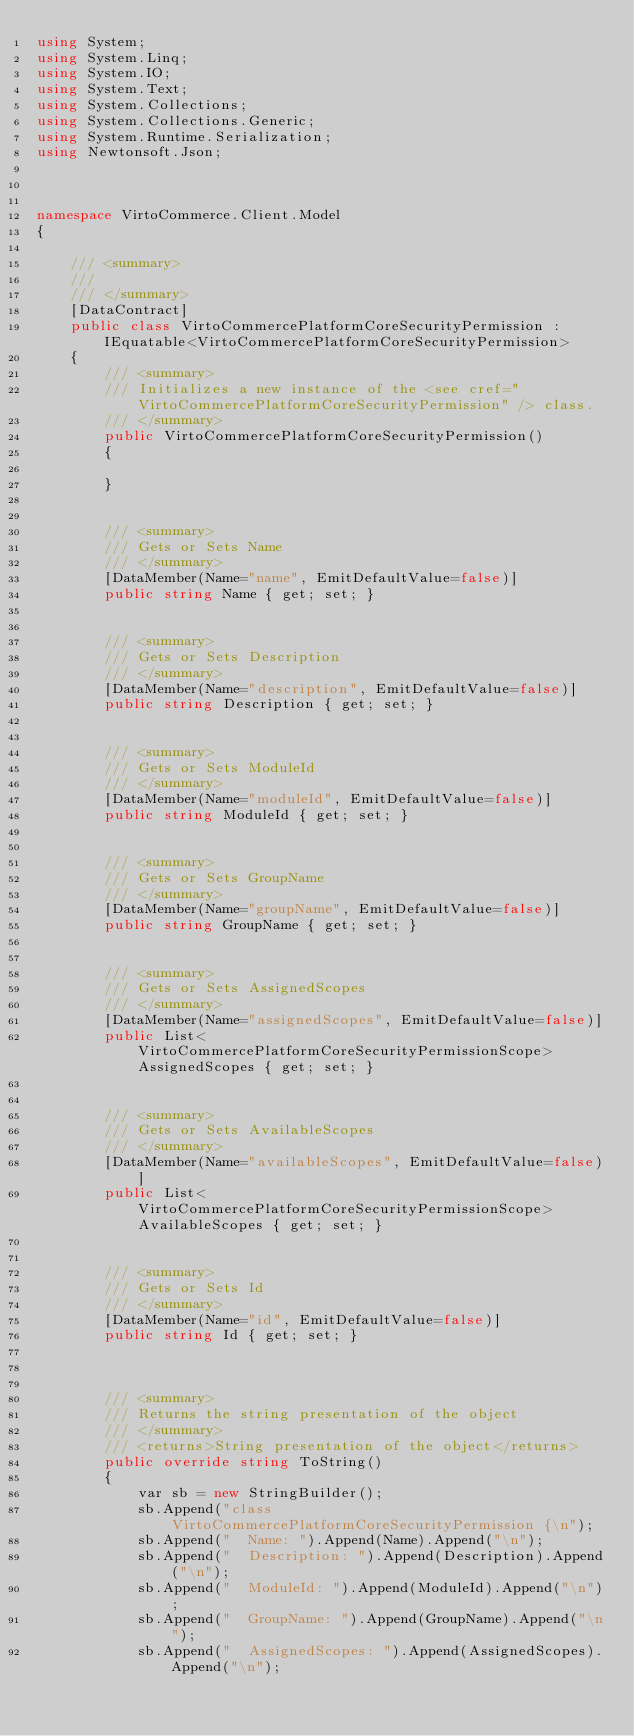Convert code to text. <code><loc_0><loc_0><loc_500><loc_500><_C#_>using System;
using System.Linq;
using System.IO;
using System.Text;
using System.Collections;
using System.Collections.Generic;
using System.Runtime.Serialization;
using Newtonsoft.Json;



namespace VirtoCommerce.Client.Model
{

    /// <summary>
    /// 
    /// </summary>
    [DataContract]
    public class VirtoCommercePlatformCoreSecurityPermission : IEquatable<VirtoCommercePlatformCoreSecurityPermission>
    {
        /// <summary>
        /// Initializes a new instance of the <see cref="VirtoCommercePlatformCoreSecurityPermission" /> class.
        /// </summary>
        public VirtoCommercePlatformCoreSecurityPermission()
        {
            
        }

        
        /// <summary>
        /// Gets or Sets Name
        /// </summary>
        [DataMember(Name="name", EmitDefaultValue=false)]
        public string Name { get; set; }
  
        
        /// <summary>
        /// Gets or Sets Description
        /// </summary>
        [DataMember(Name="description", EmitDefaultValue=false)]
        public string Description { get; set; }
  
        
        /// <summary>
        /// Gets or Sets ModuleId
        /// </summary>
        [DataMember(Name="moduleId", EmitDefaultValue=false)]
        public string ModuleId { get; set; }
  
        
        /// <summary>
        /// Gets or Sets GroupName
        /// </summary>
        [DataMember(Name="groupName", EmitDefaultValue=false)]
        public string GroupName { get; set; }
  
        
        /// <summary>
        /// Gets or Sets AssignedScopes
        /// </summary>
        [DataMember(Name="assignedScopes", EmitDefaultValue=false)]
        public List<VirtoCommercePlatformCoreSecurityPermissionScope> AssignedScopes { get; set; }
  
        
        /// <summary>
        /// Gets or Sets AvailableScopes
        /// </summary>
        [DataMember(Name="availableScopes", EmitDefaultValue=false)]
        public List<VirtoCommercePlatformCoreSecurityPermissionScope> AvailableScopes { get; set; }
  
        
        /// <summary>
        /// Gets or Sets Id
        /// </summary>
        [DataMember(Name="id", EmitDefaultValue=false)]
        public string Id { get; set; }
  
        
  
        /// <summary>
        /// Returns the string presentation of the object
        /// </summary>
        /// <returns>String presentation of the object</returns>
        public override string ToString()
        {
            var sb = new StringBuilder();
            sb.Append("class VirtoCommercePlatformCoreSecurityPermission {\n");
            sb.Append("  Name: ").Append(Name).Append("\n");
            sb.Append("  Description: ").Append(Description).Append("\n");
            sb.Append("  ModuleId: ").Append(ModuleId).Append("\n");
            sb.Append("  GroupName: ").Append(GroupName).Append("\n");
            sb.Append("  AssignedScopes: ").Append(AssignedScopes).Append("\n");</code> 